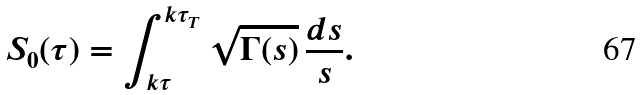<formula> <loc_0><loc_0><loc_500><loc_500>S _ { 0 } ( \tau ) = \int _ { k \tau } ^ { k \tau _ { T } } \sqrt { \Gamma ( s ) } \, \frac { d s } { s } .</formula> 